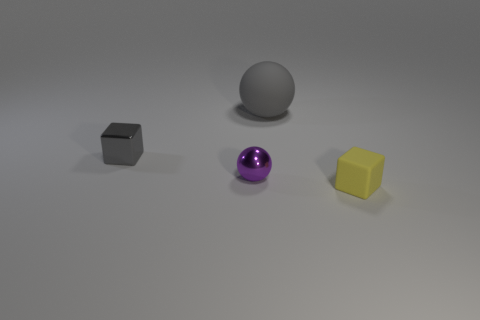There is a thing that is both behind the purple thing and to the right of the tiny purple thing; what color is it?
Your response must be concise. Gray. Are there any purple things that have the same shape as the yellow rubber thing?
Make the answer very short. No. Is the metallic cube the same color as the large ball?
Keep it short and to the point. Yes. Is there a large gray matte sphere that is on the left side of the ball behind the small gray metallic thing?
Offer a very short reply. No. What number of things are tiny things to the left of the tiny yellow rubber block or large gray rubber spheres that are right of the small purple thing?
Your answer should be very brief. 3. What number of things are either tiny red blocks or spheres that are behind the metallic cube?
Give a very brief answer. 1. What size is the gray thing behind the gray shiny block behind the cube that is in front of the small gray cube?
Provide a succinct answer. Large. There is a yellow object that is the same size as the purple metallic object; what is its material?
Provide a short and direct response. Rubber. Is there a yellow rubber block that has the same size as the gray sphere?
Your answer should be very brief. No. Does the block behind the rubber cube have the same size as the small yellow object?
Offer a terse response. Yes. 